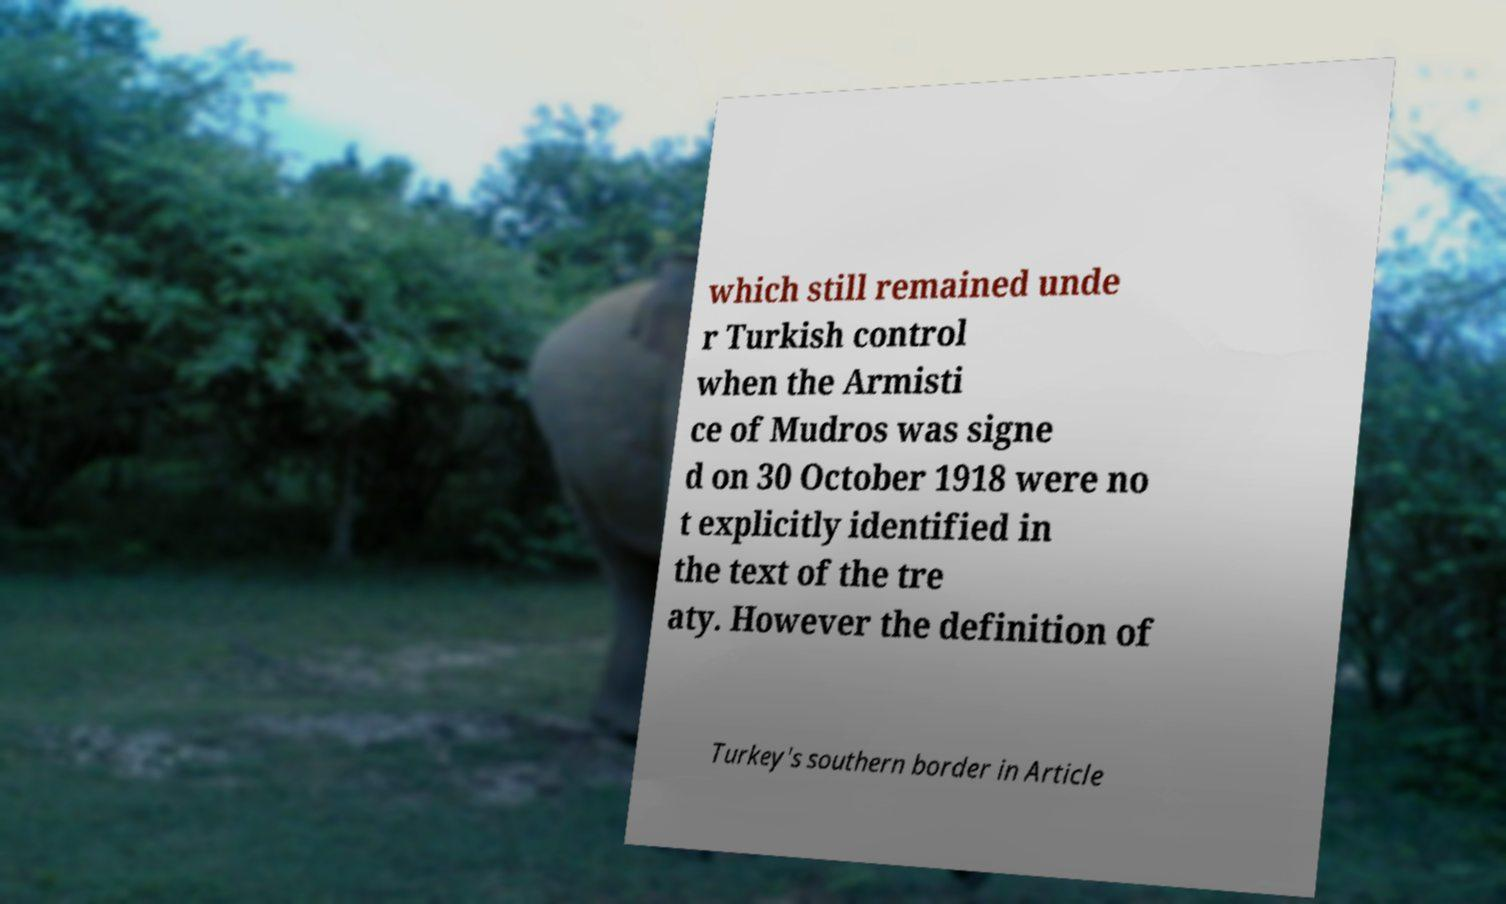Could you assist in decoding the text presented in this image and type it out clearly? which still remained unde r Turkish control when the Armisti ce of Mudros was signe d on 30 October 1918 were no t explicitly identified in the text of the tre aty. However the definition of Turkey's southern border in Article 